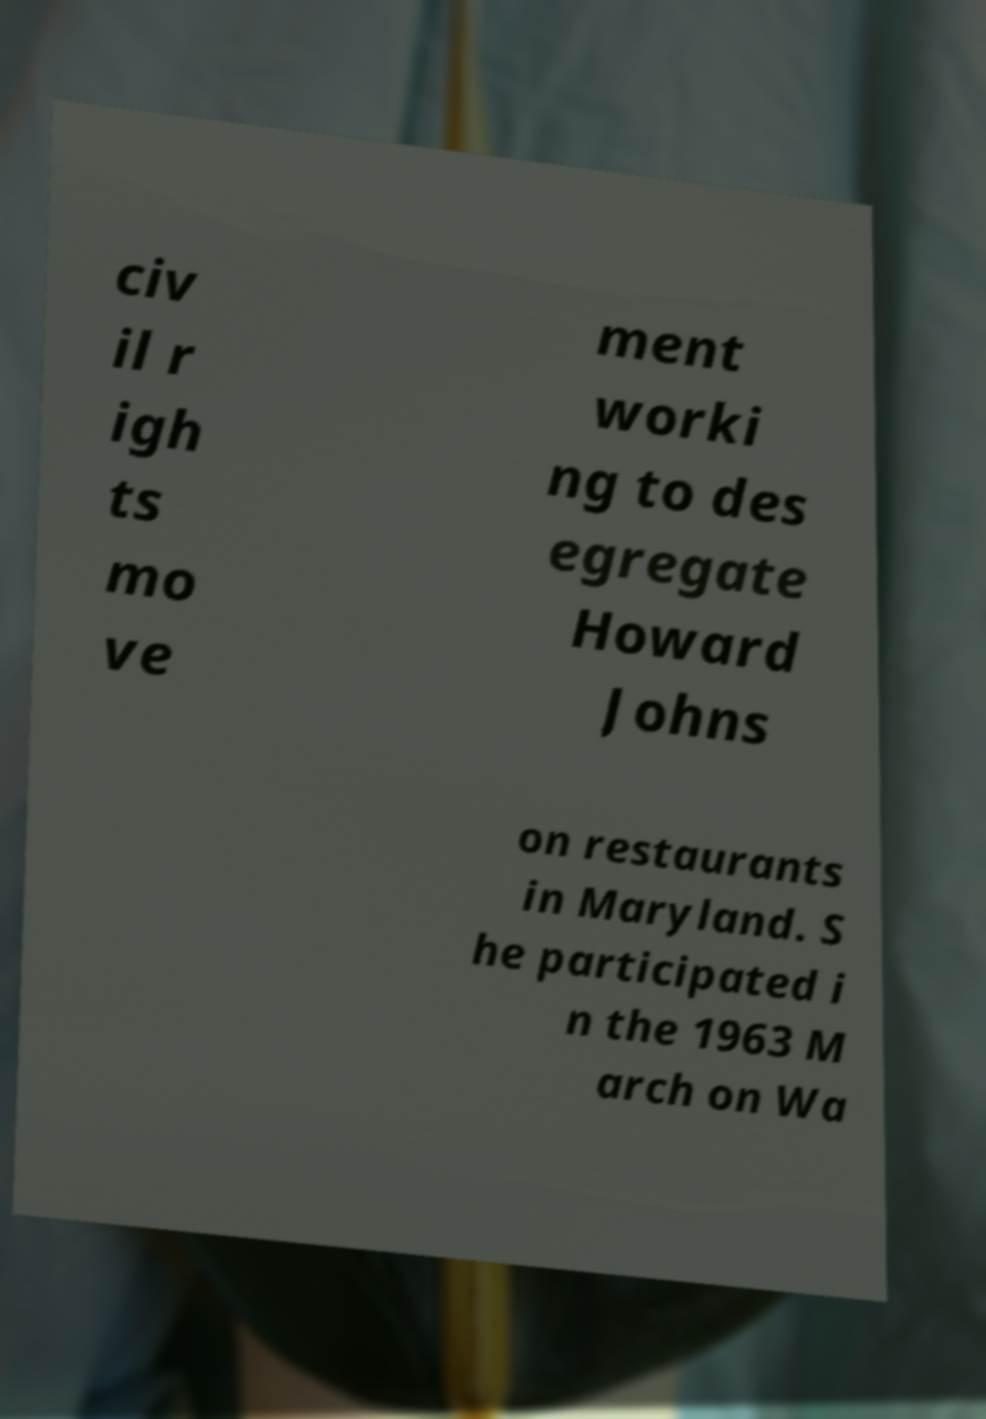Could you extract and type out the text from this image? civ il r igh ts mo ve ment worki ng to des egregate Howard Johns on restaurants in Maryland. S he participated i n the 1963 M arch on Wa 